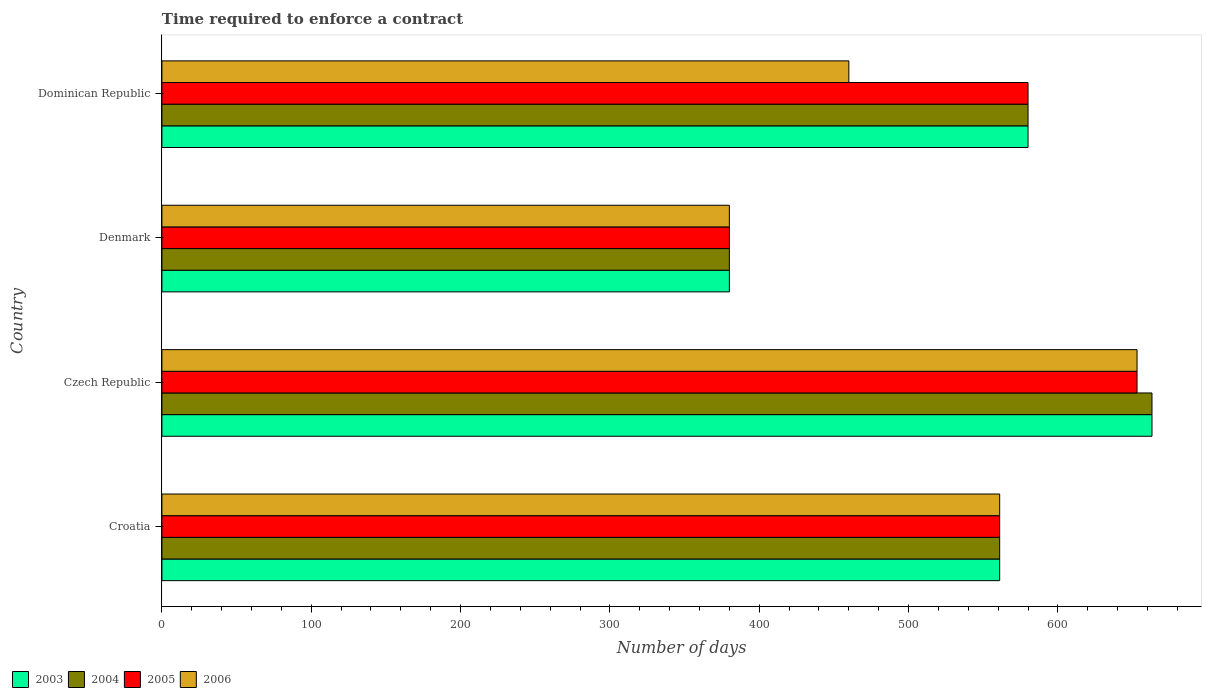How many bars are there on the 4th tick from the top?
Ensure brevity in your answer.  4. What is the label of the 1st group of bars from the top?
Offer a terse response. Dominican Republic. What is the number of days required to enforce a contract in 2006 in Dominican Republic?
Provide a succinct answer. 460. Across all countries, what is the maximum number of days required to enforce a contract in 2005?
Offer a terse response. 653. Across all countries, what is the minimum number of days required to enforce a contract in 2006?
Offer a terse response. 380. In which country was the number of days required to enforce a contract in 2003 maximum?
Make the answer very short. Czech Republic. In which country was the number of days required to enforce a contract in 2003 minimum?
Offer a terse response. Denmark. What is the total number of days required to enforce a contract in 2004 in the graph?
Ensure brevity in your answer.  2184. What is the difference between the number of days required to enforce a contract in 2004 in Czech Republic and the number of days required to enforce a contract in 2005 in Croatia?
Offer a terse response. 102. What is the average number of days required to enforce a contract in 2005 per country?
Keep it short and to the point. 543.5. What is the difference between the number of days required to enforce a contract in 2005 and number of days required to enforce a contract in 2006 in Dominican Republic?
Offer a terse response. 120. In how many countries, is the number of days required to enforce a contract in 2004 greater than 520 days?
Provide a short and direct response. 3. What is the ratio of the number of days required to enforce a contract in 2005 in Denmark to that in Dominican Republic?
Provide a short and direct response. 0.66. Is the number of days required to enforce a contract in 2005 in Denmark less than that in Dominican Republic?
Provide a succinct answer. Yes. What is the difference between the highest and the lowest number of days required to enforce a contract in 2003?
Provide a succinct answer. 283. In how many countries, is the number of days required to enforce a contract in 2005 greater than the average number of days required to enforce a contract in 2005 taken over all countries?
Provide a succinct answer. 3. What does the 3rd bar from the bottom in Czech Republic represents?
Offer a terse response. 2005. Is it the case that in every country, the sum of the number of days required to enforce a contract in 2003 and number of days required to enforce a contract in 2004 is greater than the number of days required to enforce a contract in 2005?
Provide a succinct answer. Yes. How many bars are there?
Make the answer very short. 16. Are all the bars in the graph horizontal?
Make the answer very short. Yes. How many countries are there in the graph?
Give a very brief answer. 4. What is the difference between two consecutive major ticks on the X-axis?
Give a very brief answer. 100. How many legend labels are there?
Your answer should be very brief. 4. How are the legend labels stacked?
Offer a very short reply. Horizontal. What is the title of the graph?
Make the answer very short. Time required to enforce a contract. Does "2005" appear as one of the legend labels in the graph?
Make the answer very short. Yes. What is the label or title of the X-axis?
Provide a succinct answer. Number of days. What is the Number of days of 2003 in Croatia?
Provide a short and direct response. 561. What is the Number of days of 2004 in Croatia?
Offer a very short reply. 561. What is the Number of days of 2005 in Croatia?
Provide a short and direct response. 561. What is the Number of days of 2006 in Croatia?
Keep it short and to the point. 561. What is the Number of days in 2003 in Czech Republic?
Keep it short and to the point. 663. What is the Number of days of 2004 in Czech Republic?
Keep it short and to the point. 663. What is the Number of days in 2005 in Czech Republic?
Offer a terse response. 653. What is the Number of days in 2006 in Czech Republic?
Offer a very short reply. 653. What is the Number of days in 2003 in Denmark?
Make the answer very short. 380. What is the Number of days in 2004 in Denmark?
Keep it short and to the point. 380. What is the Number of days of 2005 in Denmark?
Give a very brief answer. 380. What is the Number of days of 2006 in Denmark?
Give a very brief answer. 380. What is the Number of days in 2003 in Dominican Republic?
Give a very brief answer. 580. What is the Number of days of 2004 in Dominican Republic?
Give a very brief answer. 580. What is the Number of days in 2005 in Dominican Republic?
Provide a succinct answer. 580. What is the Number of days in 2006 in Dominican Republic?
Keep it short and to the point. 460. Across all countries, what is the maximum Number of days of 2003?
Offer a terse response. 663. Across all countries, what is the maximum Number of days in 2004?
Your response must be concise. 663. Across all countries, what is the maximum Number of days in 2005?
Provide a short and direct response. 653. Across all countries, what is the maximum Number of days in 2006?
Make the answer very short. 653. Across all countries, what is the minimum Number of days of 2003?
Provide a short and direct response. 380. Across all countries, what is the minimum Number of days of 2004?
Provide a short and direct response. 380. Across all countries, what is the minimum Number of days in 2005?
Make the answer very short. 380. Across all countries, what is the minimum Number of days in 2006?
Your response must be concise. 380. What is the total Number of days of 2003 in the graph?
Your answer should be compact. 2184. What is the total Number of days of 2004 in the graph?
Keep it short and to the point. 2184. What is the total Number of days in 2005 in the graph?
Provide a short and direct response. 2174. What is the total Number of days of 2006 in the graph?
Your answer should be compact. 2054. What is the difference between the Number of days in 2003 in Croatia and that in Czech Republic?
Give a very brief answer. -102. What is the difference between the Number of days in 2004 in Croatia and that in Czech Republic?
Give a very brief answer. -102. What is the difference between the Number of days in 2005 in Croatia and that in Czech Republic?
Ensure brevity in your answer.  -92. What is the difference between the Number of days in 2006 in Croatia and that in Czech Republic?
Make the answer very short. -92. What is the difference between the Number of days in 2003 in Croatia and that in Denmark?
Provide a short and direct response. 181. What is the difference between the Number of days of 2004 in Croatia and that in Denmark?
Ensure brevity in your answer.  181. What is the difference between the Number of days of 2005 in Croatia and that in Denmark?
Keep it short and to the point. 181. What is the difference between the Number of days of 2006 in Croatia and that in Denmark?
Keep it short and to the point. 181. What is the difference between the Number of days of 2005 in Croatia and that in Dominican Republic?
Offer a terse response. -19. What is the difference between the Number of days in 2006 in Croatia and that in Dominican Republic?
Your response must be concise. 101. What is the difference between the Number of days in 2003 in Czech Republic and that in Denmark?
Your answer should be very brief. 283. What is the difference between the Number of days of 2004 in Czech Republic and that in Denmark?
Your answer should be compact. 283. What is the difference between the Number of days in 2005 in Czech Republic and that in Denmark?
Keep it short and to the point. 273. What is the difference between the Number of days in 2006 in Czech Republic and that in Denmark?
Ensure brevity in your answer.  273. What is the difference between the Number of days of 2006 in Czech Republic and that in Dominican Republic?
Offer a terse response. 193. What is the difference between the Number of days of 2003 in Denmark and that in Dominican Republic?
Offer a terse response. -200. What is the difference between the Number of days in 2004 in Denmark and that in Dominican Republic?
Give a very brief answer. -200. What is the difference between the Number of days in 2005 in Denmark and that in Dominican Republic?
Provide a short and direct response. -200. What is the difference between the Number of days in 2006 in Denmark and that in Dominican Republic?
Offer a terse response. -80. What is the difference between the Number of days in 2003 in Croatia and the Number of days in 2004 in Czech Republic?
Make the answer very short. -102. What is the difference between the Number of days of 2003 in Croatia and the Number of days of 2005 in Czech Republic?
Your answer should be very brief. -92. What is the difference between the Number of days of 2003 in Croatia and the Number of days of 2006 in Czech Republic?
Make the answer very short. -92. What is the difference between the Number of days of 2004 in Croatia and the Number of days of 2005 in Czech Republic?
Offer a very short reply. -92. What is the difference between the Number of days in 2004 in Croatia and the Number of days in 2006 in Czech Republic?
Your response must be concise. -92. What is the difference between the Number of days of 2005 in Croatia and the Number of days of 2006 in Czech Republic?
Offer a very short reply. -92. What is the difference between the Number of days of 2003 in Croatia and the Number of days of 2004 in Denmark?
Keep it short and to the point. 181. What is the difference between the Number of days in 2003 in Croatia and the Number of days in 2005 in Denmark?
Give a very brief answer. 181. What is the difference between the Number of days in 2003 in Croatia and the Number of days in 2006 in Denmark?
Make the answer very short. 181. What is the difference between the Number of days in 2004 in Croatia and the Number of days in 2005 in Denmark?
Provide a succinct answer. 181. What is the difference between the Number of days in 2004 in Croatia and the Number of days in 2006 in Denmark?
Give a very brief answer. 181. What is the difference between the Number of days in 2005 in Croatia and the Number of days in 2006 in Denmark?
Make the answer very short. 181. What is the difference between the Number of days of 2003 in Croatia and the Number of days of 2005 in Dominican Republic?
Ensure brevity in your answer.  -19. What is the difference between the Number of days of 2003 in Croatia and the Number of days of 2006 in Dominican Republic?
Ensure brevity in your answer.  101. What is the difference between the Number of days in 2004 in Croatia and the Number of days in 2006 in Dominican Republic?
Give a very brief answer. 101. What is the difference between the Number of days of 2005 in Croatia and the Number of days of 2006 in Dominican Republic?
Your answer should be very brief. 101. What is the difference between the Number of days of 2003 in Czech Republic and the Number of days of 2004 in Denmark?
Your answer should be very brief. 283. What is the difference between the Number of days of 2003 in Czech Republic and the Number of days of 2005 in Denmark?
Make the answer very short. 283. What is the difference between the Number of days in 2003 in Czech Republic and the Number of days in 2006 in Denmark?
Provide a short and direct response. 283. What is the difference between the Number of days of 2004 in Czech Republic and the Number of days of 2005 in Denmark?
Your answer should be compact. 283. What is the difference between the Number of days of 2004 in Czech Republic and the Number of days of 2006 in Denmark?
Ensure brevity in your answer.  283. What is the difference between the Number of days of 2005 in Czech Republic and the Number of days of 2006 in Denmark?
Make the answer very short. 273. What is the difference between the Number of days of 2003 in Czech Republic and the Number of days of 2004 in Dominican Republic?
Give a very brief answer. 83. What is the difference between the Number of days in 2003 in Czech Republic and the Number of days in 2006 in Dominican Republic?
Offer a terse response. 203. What is the difference between the Number of days in 2004 in Czech Republic and the Number of days in 2006 in Dominican Republic?
Your answer should be very brief. 203. What is the difference between the Number of days of 2005 in Czech Republic and the Number of days of 2006 in Dominican Republic?
Keep it short and to the point. 193. What is the difference between the Number of days in 2003 in Denmark and the Number of days in 2004 in Dominican Republic?
Provide a succinct answer. -200. What is the difference between the Number of days of 2003 in Denmark and the Number of days of 2005 in Dominican Republic?
Your response must be concise. -200. What is the difference between the Number of days in 2003 in Denmark and the Number of days in 2006 in Dominican Republic?
Provide a short and direct response. -80. What is the difference between the Number of days of 2004 in Denmark and the Number of days of 2005 in Dominican Republic?
Ensure brevity in your answer.  -200. What is the difference between the Number of days of 2004 in Denmark and the Number of days of 2006 in Dominican Republic?
Your response must be concise. -80. What is the difference between the Number of days in 2005 in Denmark and the Number of days in 2006 in Dominican Republic?
Provide a short and direct response. -80. What is the average Number of days in 2003 per country?
Your answer should be very brief. 546. What is the average Number of days in 2004 per country?
Offer a terse response. 546. What is the average Number of days in 2005 per country?
Your response must be concise. 543.5. What is the average Number of days of 2006 per country?
Ensure brevity in your answer.  513.5. What is the difference between the Number of days of 2003 and Number of days of 2004 in Croatia?
Keep it short and to the point. 0. What is the difference between the Number of days in 2003 and Number of days in 2006 in Croatia?
Your answer should be very brief. 0. What is the difference between the Number of days in 2004 and Number of days in 2005 in Croatia?
Your answer should be very brief. 0. What is the difference between the Number of days in 2003 and Number of days in 2004 in Czech Republic?
Ensure brevity in your answer.  0. What is the difference between the Number of days in 2003 and Number of days in 2005 in Czech Republic?
Provide a succinct answer. 10. What is the difference between the Number of days in 2004 and Number of days in 2005 in Czech Republic?
Your answer should be compact. 10. What is the difference between the Number of days in 2005 and Number of days in 2006 in Czech Republic?
Provide a short and direct response. 0. What is the difference between the Number of days of 2003 and Number of days of 2004 in Denmark?
Ensure brevity in your answer.  0. What is the difference between the Number of days of 2003 and Number of days of 2005 in Denmark?
Provide a short and direct response. 0. What is the difference between the Number of days of 2004 and Number of days of 2005 in Denmark?
Ensure brevity in your answer.  0. What is the difference between the Number of days of 2004 and Number of days of 2006 in Denmark?
Your answer should be compact. 0. What is the difference between the Number of days in 2003 and Number of days in 2004 in Dominican Republic?
Give a very brief answer. 0. What is the difference between the Number of days of 2003 and Number of days of 2005 in Dominican Republic?
Ensure brevity in your answer.  0. What is the difference between the Number of days of 2003 and Number of days of 2006 in Dominican Republic?
Offer a very short reply. 120. What is the difference between the Number of days of 2004 and Number of days of 2006 in Dominican Republic?
Ensure brevity in your answer.  120. What is the difference between the Number of days of 2005 and Number of days of 2006 in Dominican Republic?
Keep it short and to the point. 120. What is the ratio of the Number of days of 2003 in Croatia to that in Czech Republic?
Your response must be concise. 0.85. What is the ratio of the Number of days of 2004 in Croatia to that in Czech Republic?
Your answer should be very brief. 0.85. What is the ratio of the Number of days of 2005 in Croatia to that in Czech Republic?
Make the answer very short. 0.86. What is the ratio of the Number of days in 2006 in Croatia to that in Czech Republic?
Give a very brief answer. 0.86. What is the ratio of the Number of days in 2003 in Croatia to that in Denmark?
Your answer should be very brief. 1.48. What is the ratio of the Number of days of 2004 in Croatia to that in Denmark?
Your answer should be very brief. 1.48. What is the ratio of the Number of days in 2005 in Croatia to that in Denmark?
Your answer should be very brief. 1.48. What is the ratio of the Number of days in 2006 in Croatia to that in Denmark?
Provide a short and direct response. 1.48. What is the ratio of the Number of days of 2003 in Croatia to that in Dominican Republic?
Your answer should be very brief. 0.97. What is the ratio of the Number of days of 2004 in Croatia to that in Dominican Republic?
Offer a terse response. 0.97. What is the ratio of the Number of days in 2005 in Croatia to that in Dominican Republic?
Give a very brief answer. 0.97. What is the ratio of the Number of days of 2006 in Croatia to that in Dominican Republic?
Keep it short and to the point. 1.22. What is the ratio of the Number of days in 2003 in Czech Republic to that in Denmark?
Keep it short and to the point. 1.74. What is the ratio of the Number of days in 2004 in Czech Republic to that in Denmark?
Provide a succinct answer. 1.74. What is the ratio of the Number of days in 2005 in Czech Republic to that in Denmark?
Provide a short and direct response. 1.72. What is the ratio of the Number of days of 2006 in Czech Republic to that in Denmark?
Provide a short and direct response. 1.72. What is the ratio of the Number of days in 2003 in Czech Republic to that in Dominican Republic?
Provide a short and direct response. 1.14. What is the ratio of the Number of days in 2004 in Czech Republic to that in Dominican Republic?
Your response must be concise. 1.14. What is the ratio of the Number of days in 2005 in Czech Republic to that in Dominican Republic?
Provide a short and direct response. 1.13. What is the ratio of the Number of days in 2006 in Czech Republic to that in Dominican Republic?
Ensure brevity in your answer.  1.42. What is the ratio of the Number of days of 2003 in Denmark to that in Dominican Republic?
Give a very brief answer. 0.66. What is the ratio of the Number of days of 2004 in Denmark to that in Dominican Republic?
Ensure brevity in your answer.  0.66. What is the ratio of the Number of days of 2005 in Denmark to that in Dominican Republic?
Your answer should be very brief. 0.66. What is the ratio of the Number of days of 2006 in Denmark to that in Dominican Republic?
Offer a very short reply. 0.83. What is the difference between the highest and the second highest Number of days of 2006?
Offer a very short reply. 92. What is the difference between the highest and the lowest Number of days in 2003?
Give a very brief answer. 283. What is the difference between the highest and the lowest Number of days of 2004?
Offer a terse response. 283. What is the difference between the highest and the lowest Number of days in 2005?
Give a very brief answer. 273. What is the difference between the highest and the lowest Number of days of 2006?
Your answer should be compact. 273. 